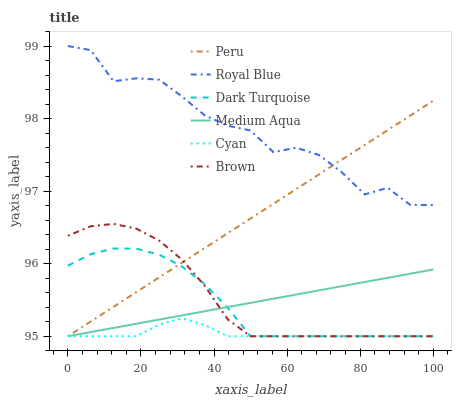Does Cyan have the minimum area under the curve?
Answer yes or no. Yes. Does Royal Blue have the maximum area under the curve?
Answer yes or no. Yes. Does Dark Turquoise have the minimum area under the curve?
Answer yes or no. No. Does Dark Turquoise have the maximum area under the curve?
Answer yes or no. No. Is Peru the smoothest?
Answer yes or no. Yes. Is Royal Blue the roughest?
Answer yes or no. Yes. Is Dark Turquoise the smoothest?
Answer yes or no. No. Is Dark Turquoise the roughest?
Answer yes or no. No. Does Brown have the lowest value?
Answer yes or no. Yes. Does Royal Blue have the lowest value?
Answer yes or no. No. Does Royal Blue have the highest value?
Answer yes or no. Yes. Does Dark Turquoise have the highest value?
Answer yes or no. No. Is Dark Turquoise less than Royal Blue?
Answer yes or no. Yes. Is Royal Blue greater than Cyan?
Answer yes or no. Yes. Does Dark Turquoise intersect Cyan?
Answer yes or no. Yes. Is Dark Turquoise less than Cyan?
Answer yes or no. No. Is Dark Turquoise greater than Cyan?
Answer yes or no. No. Does Dark Turquoise intersect Royal Blue?
Answer yes or no. No. 